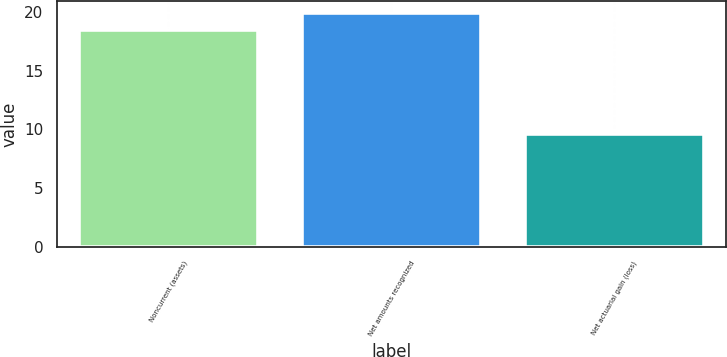<chart> <loc_0><loc_0><loc_500><loc_500><bar_chart><fcel>Noncurrent (assets)<fcel>Net amounts recognized<fcel>Net actuarial gain (loss)<nl><fcel>18.5<fcel>19.9<fcel>9.6<nl></chart> 